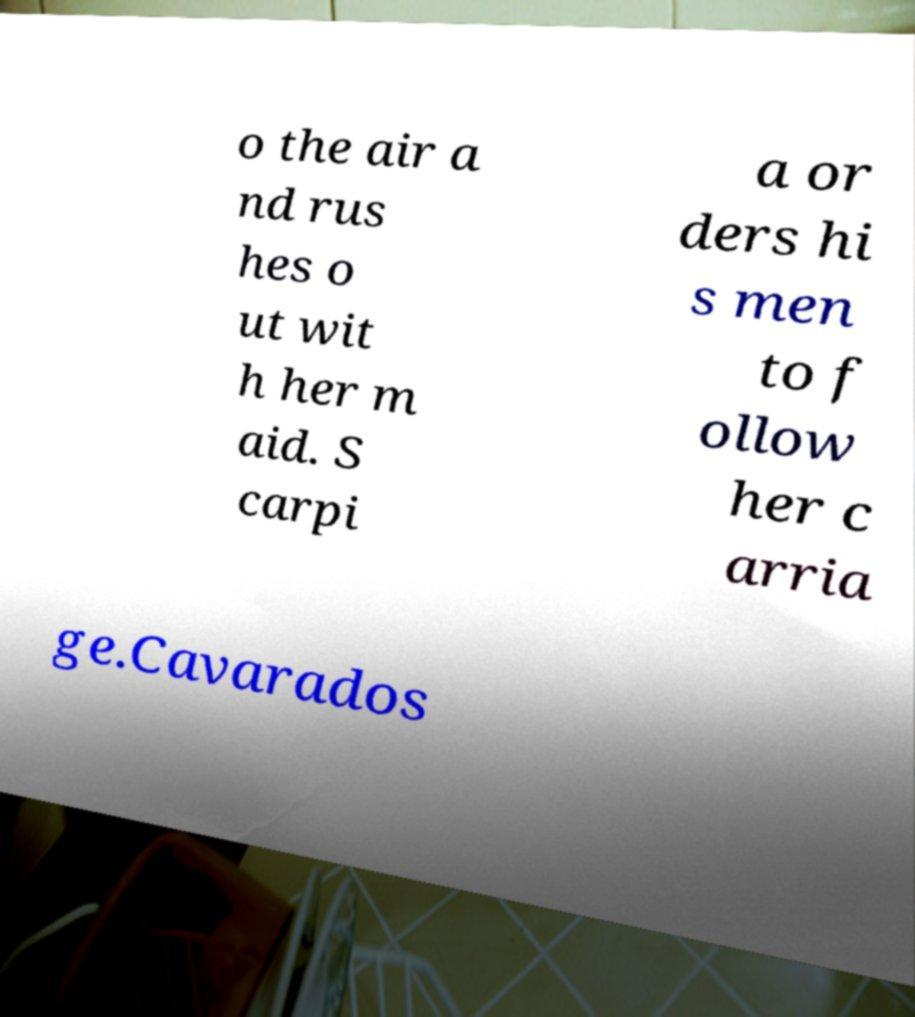Could you extract and type out the text from this image? o the air a nd rus hes o ut wit h her m aid. S carpi a or ders hi s men to f ollow her c arria ge.Cavarados 